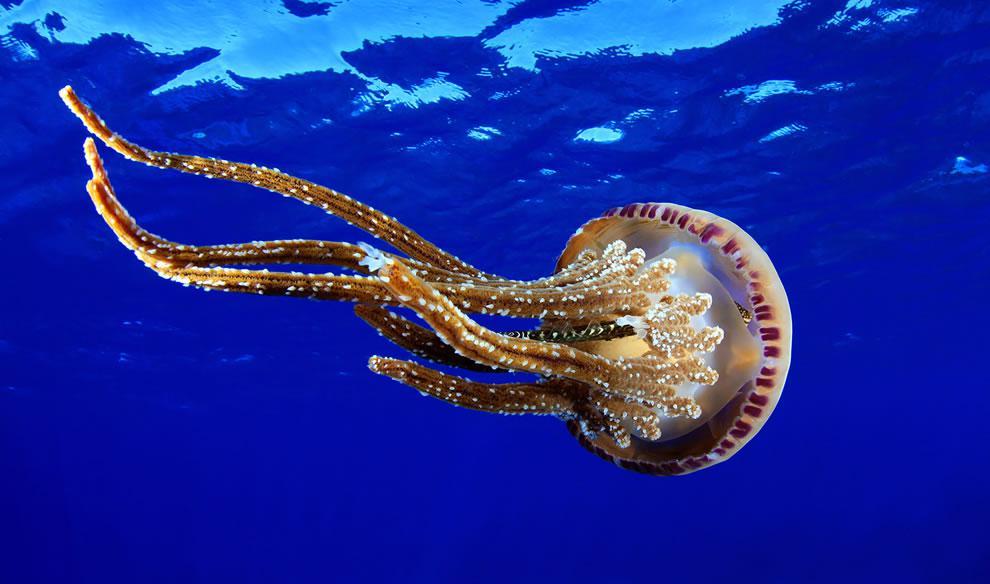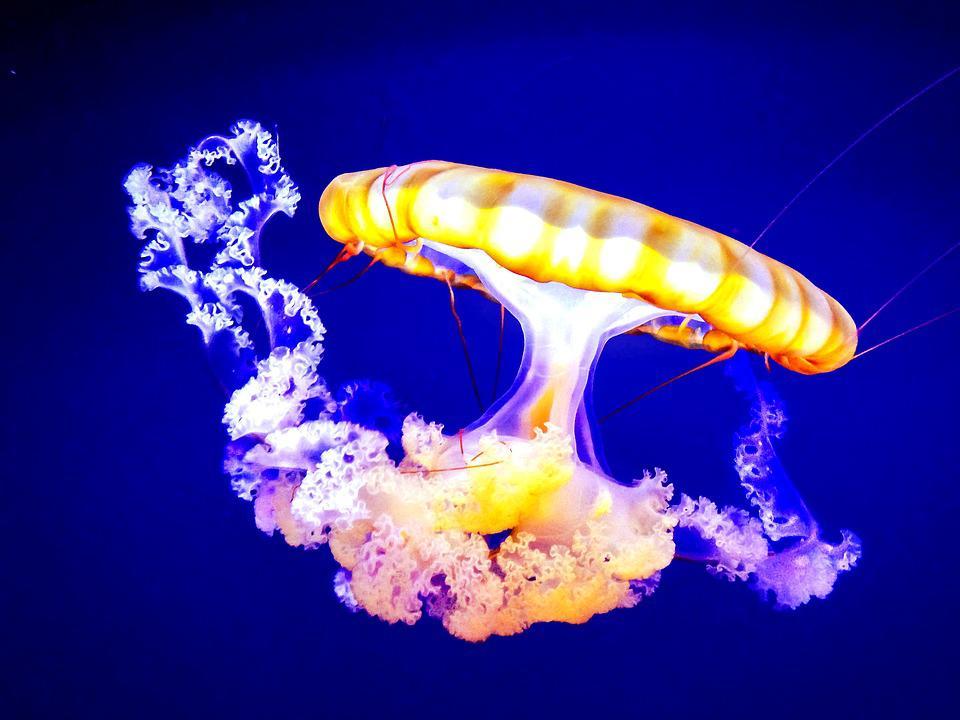The first image is the image on the left, the second image is the image on the right. Considering the images on both sides, is "There are three jellyfish" valid? Answer yes or no. No. 